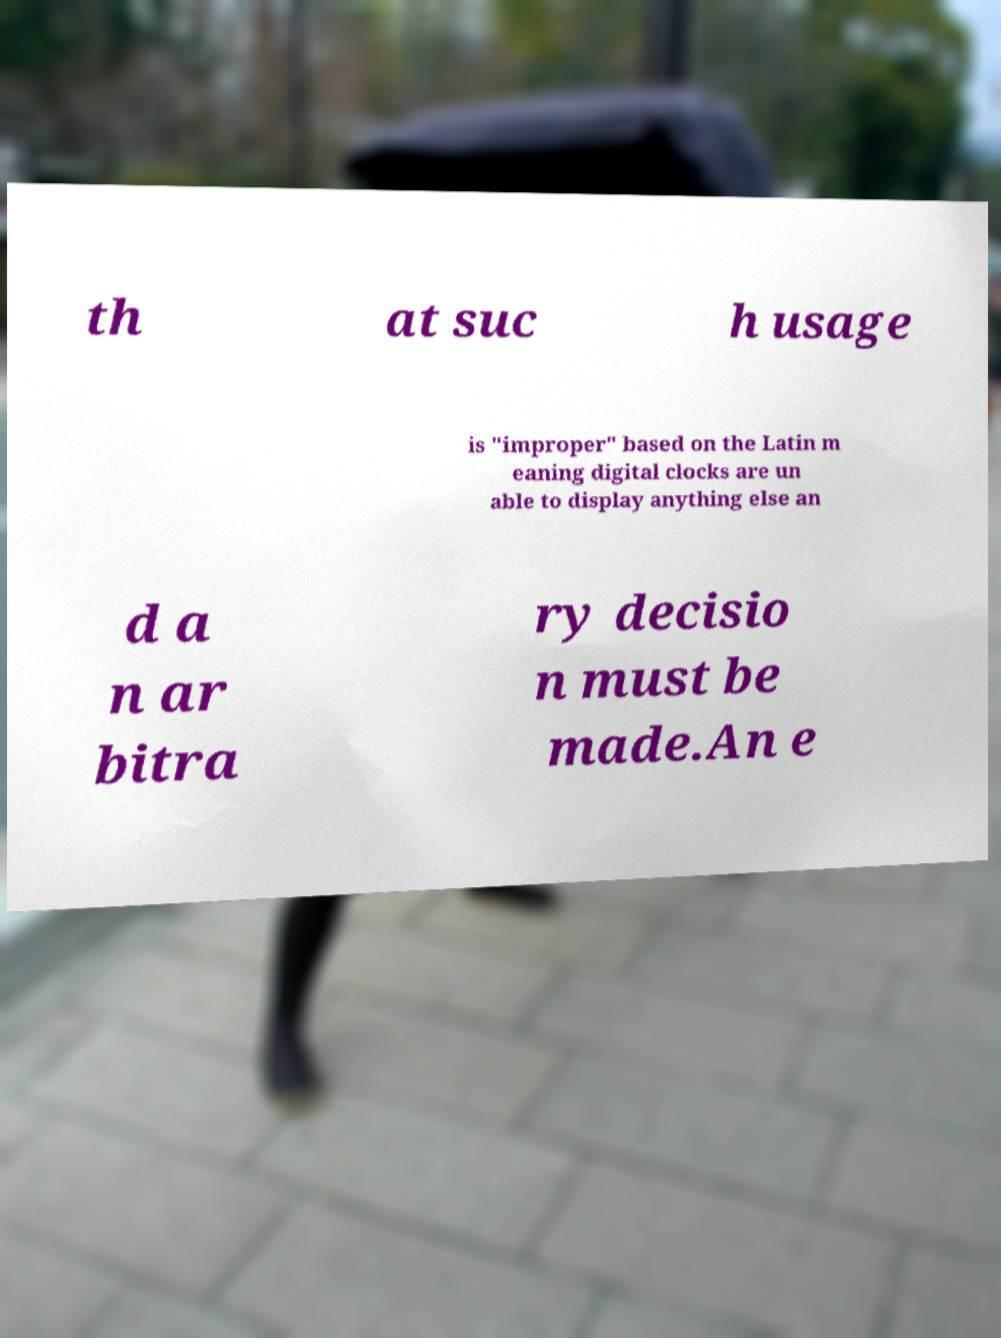Can you accurately transcribe the text from the provided image for me? th at suc h usage is "improper" based on the Latin m eaning digital clocks are un able to display anything else an d a n ar bitra ry decisio n must be made.An e 